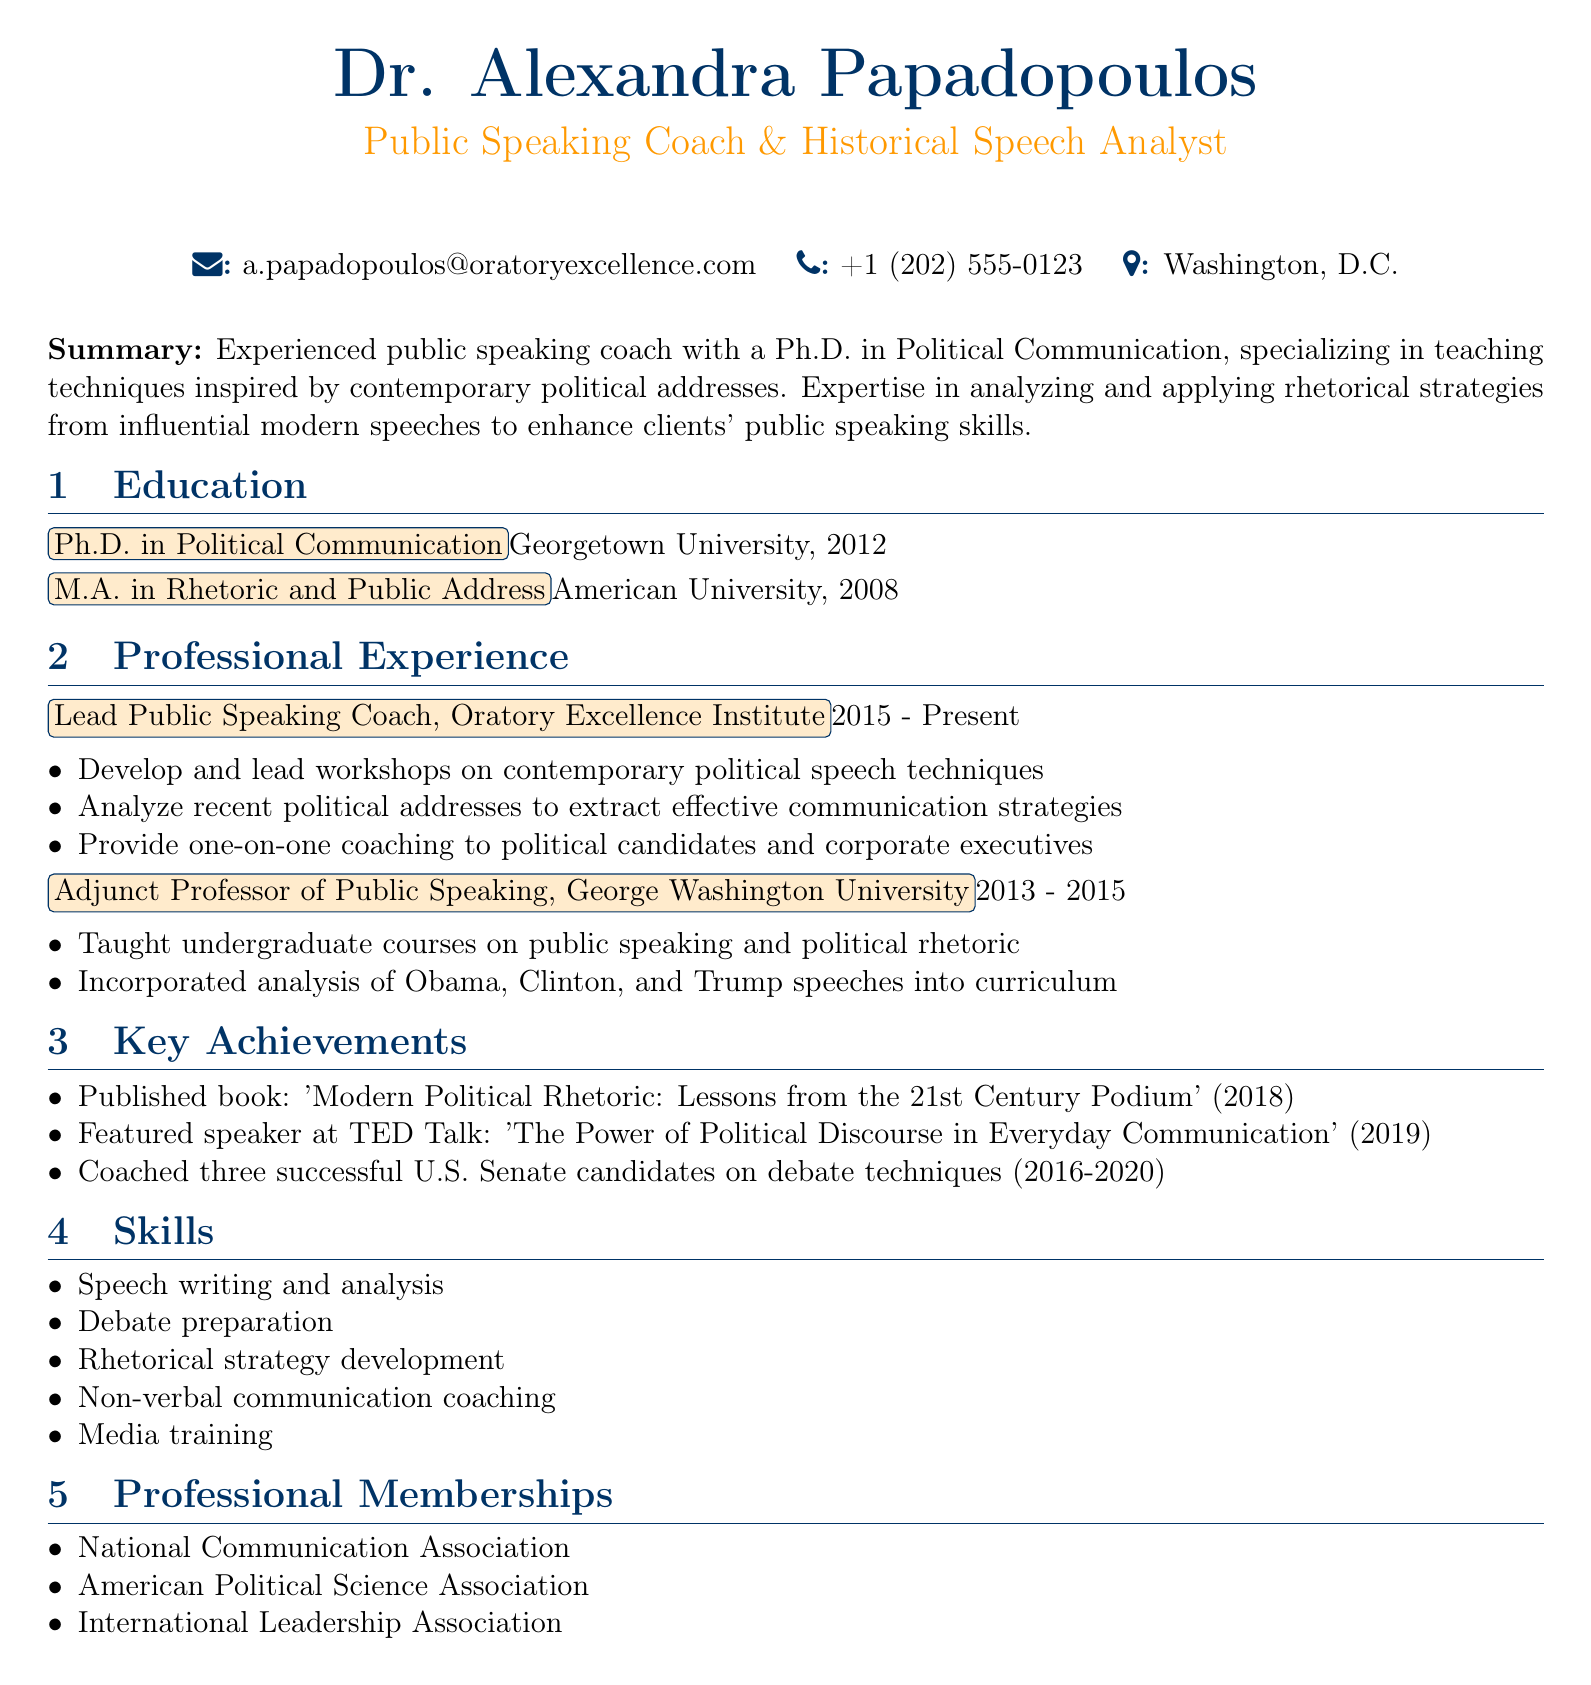what is Dr. Alexandra Papadopoulos's title? The title is presented at the beginning of the document, indicating her professional role.
Answer: Public Speaking Coach & Historical Speech Analyst which university did Dr. Papadopoulos obtain her Ph.D. from? The educational background includes the institutions where degrees were earned, including the Ph.D.
Answer: Georgetown University what is the main focus of Dr. Papadopoulos's coaching? The summary section outlines her area of specialization and expertise.
Answer: Techniques inspired by contemporary political addresses how many key achievements are listed in the document? The key achievements section enumerates specific accomplishments, which can be counted.
Answer: Three what position did Dr. Papadopoulos hold at George Washington University? The professional experience section specifies her role at that institution.
Answer: Adjunct Professor of Public Speaking which skill involves helping clients prepare for discussions? The skills section lists her abilities, one of which pertains to a specific aspect of public speaking.
Answer: Debate preparation when was Dr. Papadopoulos's book published? The key achievements section provides the year of publication for her book.
Answer: 2018 how many years did Dr. Papadopoulos work as an adjunct professor? The professional experience section provides the duration of her work in that position.
Answer: Two years what are the three professional memberships mentioned? The professional memberships section lists organizations she is part of, specifically their names.
Answer: National Communication Association, American Political Science Association, International Leadership Association 